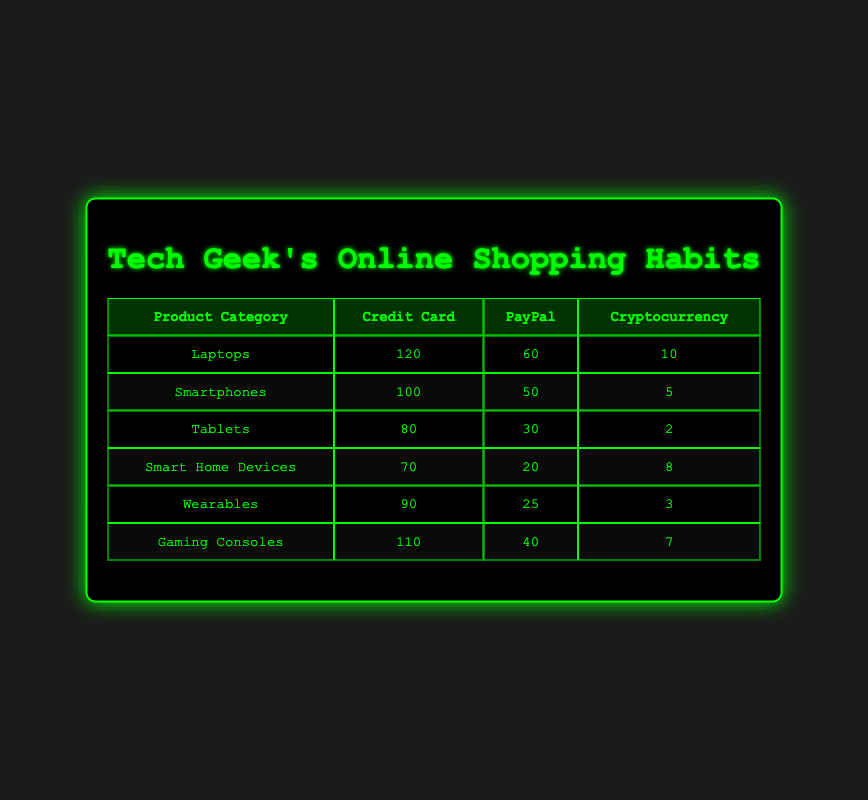What is the highest frequency for credit card payments among product categories? From the table, the highest frequency for credit card payments is found in the Laptops category with a frequency of 120.
Answer: 120 Which product category has the lowest frequency for cryptocurrency payments? The product category with the lowest frequency for cryptocurrency payments, according to the table, is Tablets, with a frequency of 2.
Answer: 2 What is the sum of frequencies for PayPal payments across all product categories? To find the sum for PayPal payments, we add the frequencies: 60 (Laptops) + 50 (Smartphones) + 30 (Tablets) + 20 (Smart Home Devices) + 25 (Wearables) + 40 (Gaming Consoles) = 225.
Answer: 225 Is the frequency of credit card payments for Gaming Consoles greater than the total frequency of cryptocurrency payments across all categories? The frequency of credit card payments for Gaming Consoles is 110. The total frequency of cryptocurrency payments is calculated as: 10 (Laptops) + 5 (Smartphones) + 2 (Tablets) + 8 (Smart Home Devices) + 3 (Wearables) + 7 (Gaming Consoles) = 35. Since 110 is greater than 35, the answer is yes.
Answer: Yes What is the average frequency of PayPal payments for Tablets and Smart Home Devices? To find the average frequency, first we sum the frequencies for PayPal payments in these categories: 30 (Tablets) + 20 (Smart Home Devices) = 50. There are 2 categories, so the average is 50 / 2 = 25.
Answer: 25 